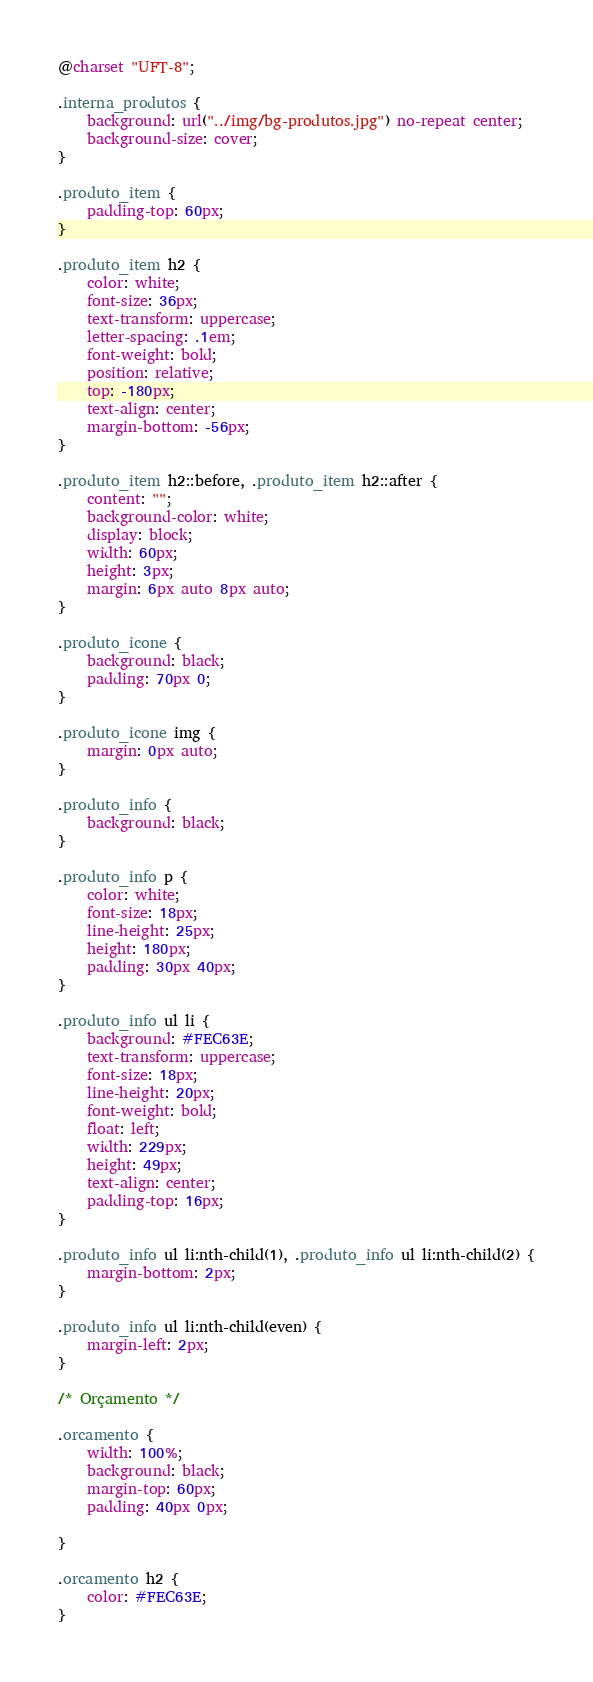Convert code to text. <code><loc_0><loc_0><loc_500><loc_500><_CSS_>@charset "UFT-8";

.interna_produtos {
    background: url("../img/bg-produtos.jpg") no-repeat center;
    background-size: cover;
}

.produto_item {
    padding-top: 60px;
}

.produto_item h2 {
    color: white;
    font-size: 36px;
    text-transform: uppercase;
    letter-spacing: .1em;
    font-weight: bold;
    position: relative;
    top: -180px;
    text-align: center;
    margin-bottom: -56px;
}

.produto_item h2::before, .produto_item h2::after {
    content: "";
    background-color: white;
    display: block;
    width: 60px;
    height: 3px;
    margin: 6px auto 8px auto;
}

.produto_icone {
    background: black;
    padding: 70px 0;
}

.produto_icone img {
    margin: 0px auto;
}

.produto_info {
    background: black;
}

.produto_info p {
    color: white;
    font-size: 18px;
    line-height: 25px;
    height: 180px;
    padding: 30px 40px;
}

.produto_info ul li {
    background: #FEC63E;
    text-transform: uppercase;
    font-size: 18px;
    line-height: 20px;
    font-weight: bold;
    float: left;
    width: 229px;
    height: 49px;
    text-align: center;
    padding-top: 16px;
}

.produto_info ul li:nth-child(1), .produto_info ul li:nth-child(2) {
    margin-bottom: 2px;
}

.produto_info ul li:nth-child(even) {
    margin-left: 2px;
}

/* Orçamento */

.orcamento {
    width: 100%;
    background: black;
    margin-top: 60px;
    padding: 40px 0px;

}

.orcamento h2 {
    color: #FEC63E;
}
</code> 